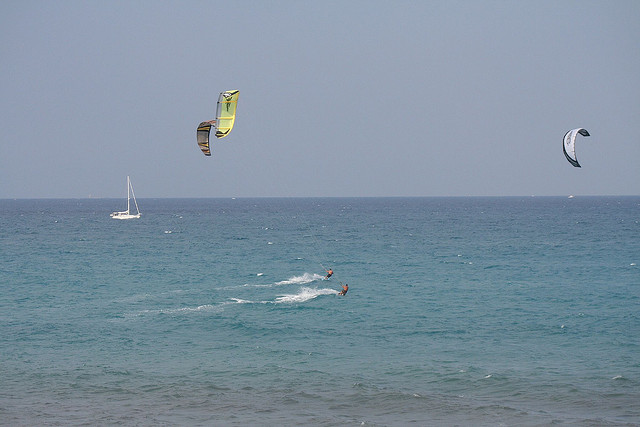Are there any indicators of the skill level or experience of the kitesurfers in this image? Several indicators can suggest the skill level of kitesurfers. Their kite control, stance, and how they handle the board all showcase proficiency. In this image, both individuals have their kites well-positioned in the sky, implying good control. The closest kitesurfer maintains a dynamic posture with the board cutting through the water, which points to an experienced rider. The fact that they're operating within close proximity to each other and to the sailboat without apparent issues also suggests a strong awareness of their surroundings, which is characteristic of experienced kitesurfers. 